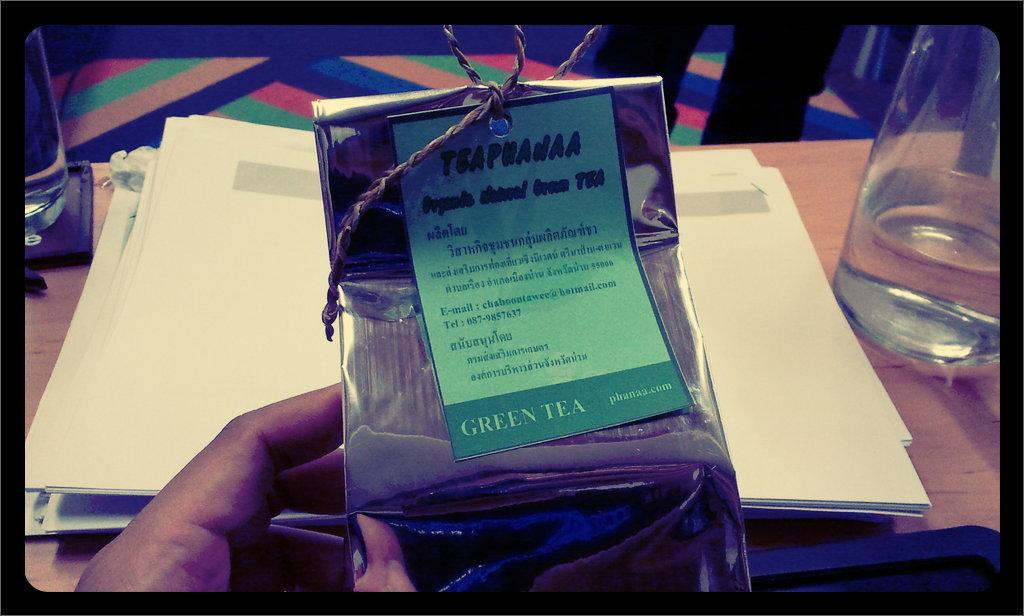What is the brand of green tea?
Your answer should be compact. Teaphanaa. 